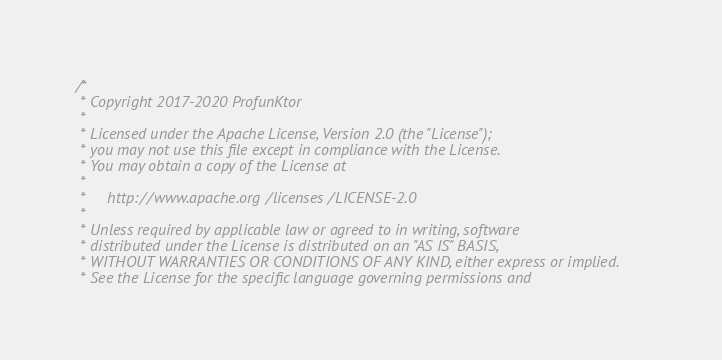Convert code to text. <code><loc_0><loc_0><loc_500><loc_500><_Scala_>/*
 * Copyright 2017-2020 ProfunKtor
 *
 * Licensed under the Apache License, Version 2.0 (the "License");
 * you may not use this file except in compliance with the License.
 * You may obtain a copy of the License at
 *
 *     http://www.apache.org/licenses/LICENSE-2.0
 *
 * Unless required by applicable law or agreed to in writing, software
 * distributed under the License is distributed on an "AS IS" BASIS,
 * WITHOUT WARRANTIES OR CONDITIONS OF ANY KIND, either express or implied.
 * See the License for the specific language governing permissions and</code> 